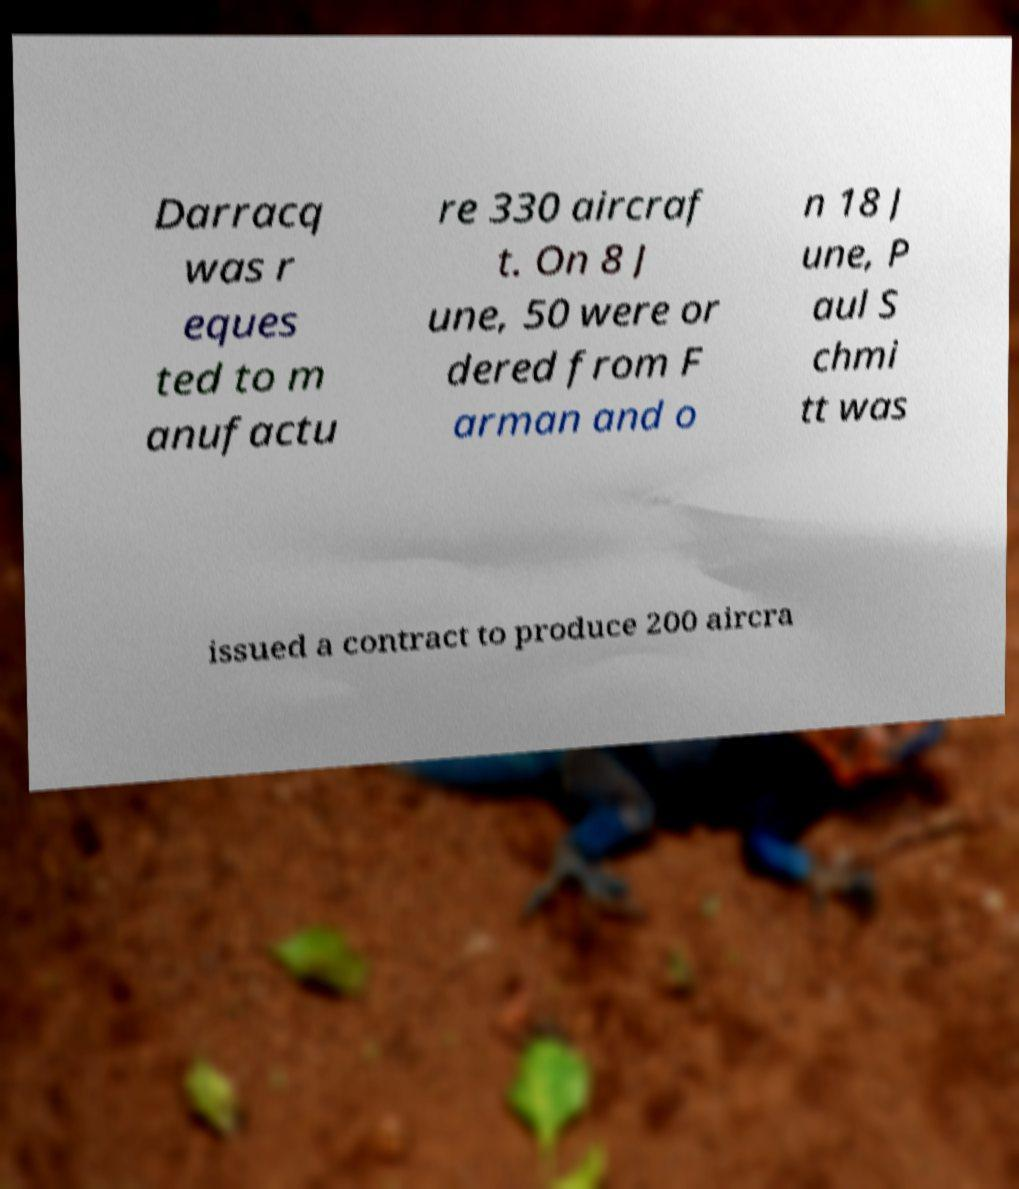Please identify and transcribe the text found in this image. Darracq was r eques ted to m anufactu re 330 aircraf t. On 8 J une, 50 were or dered from F arman and o n 18 J une, P aul S chmi tt was issued a contract to produce 200 aircra 